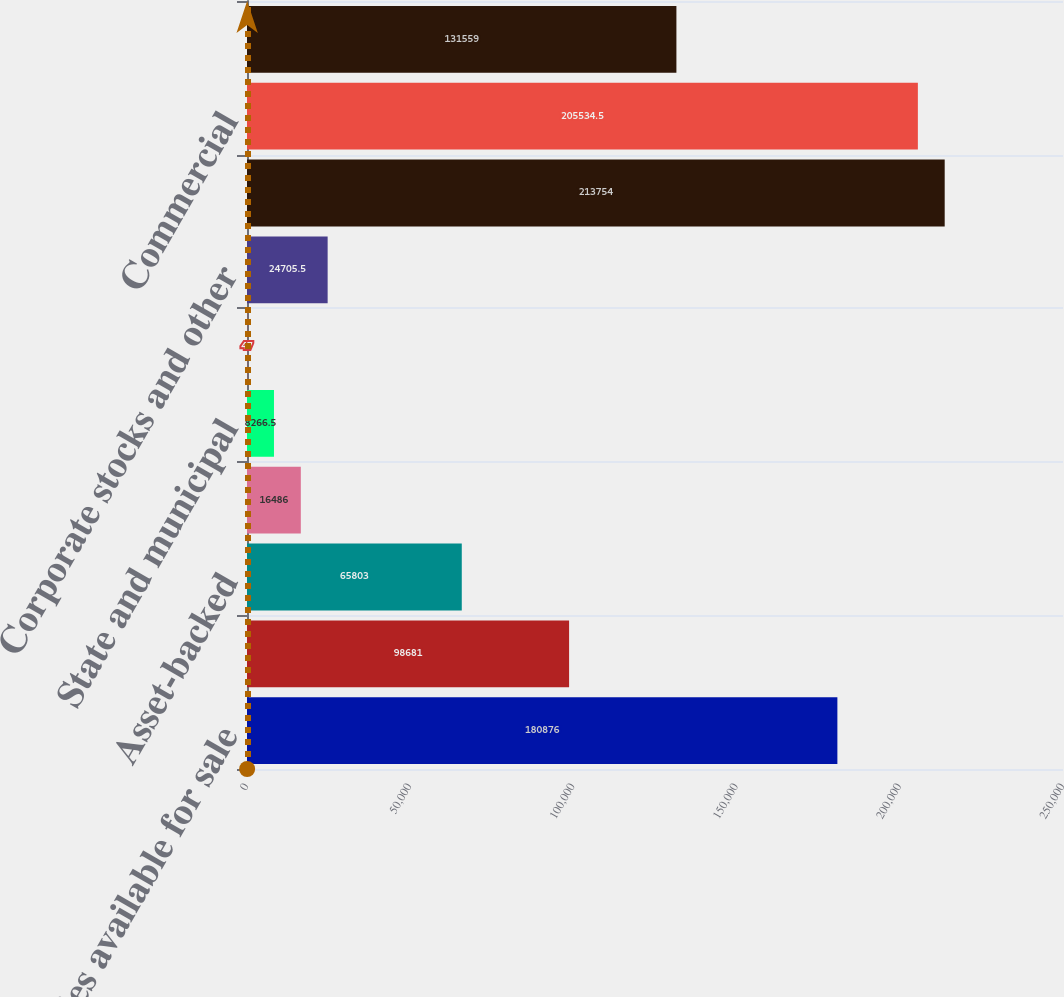Convert chart to OTSL. <chart><loc_0><loc_0><loc_500><loc_500><bar_chart><fcel>Securities available for sale<fcel>Commercial mortgage-backed<fcel>Asset-backed<fcel>US Treasury and government<fcel>State and municipal<fcel>Other debt<fcel>Corporate stocks and other<fcel>Total securities available for<fcel>Commercial<fcel>Commercial real estate<nl><fcel>180876<fcel>98681<fcel>65803<fcel>16486<fcel>8266.5<fcel>47<fcel>24705.5<fcel>213754<fcel>205534<fcel>131559<nl></chart> 